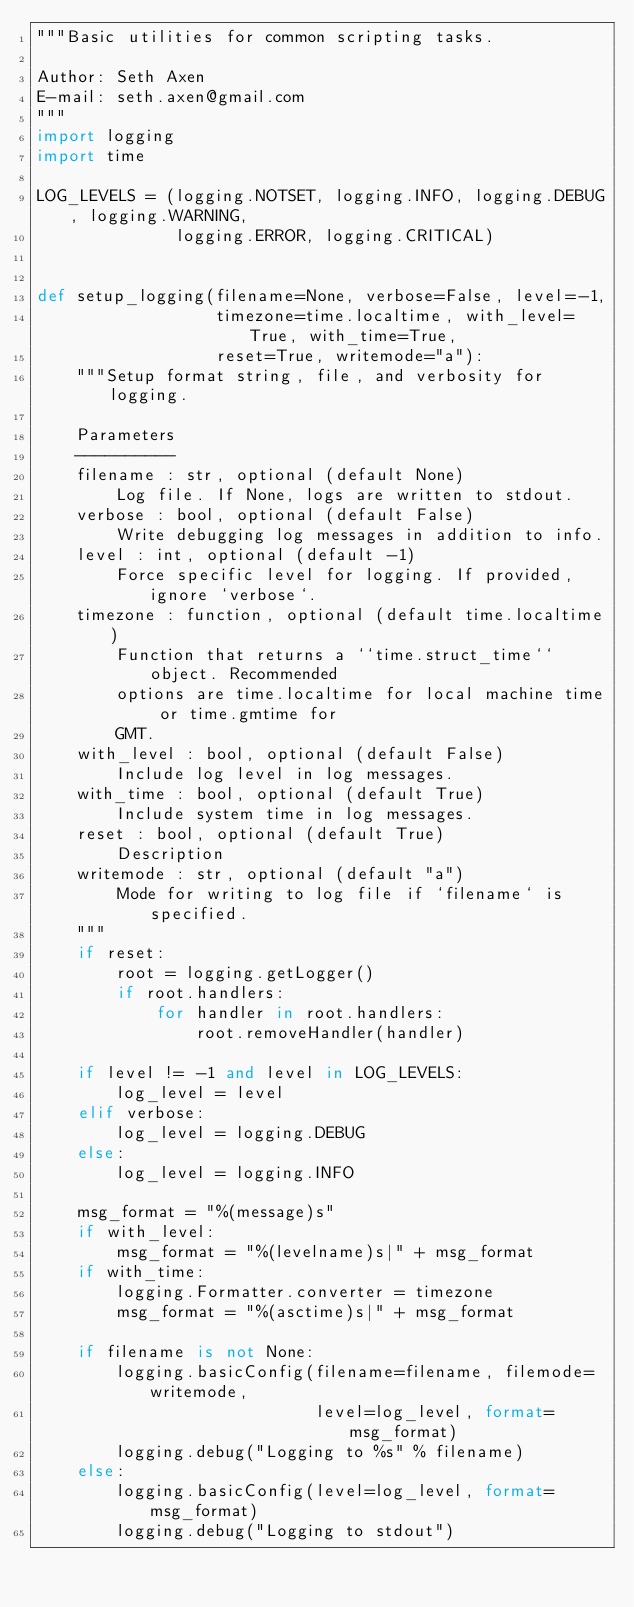<code> <loc_0><loc_0><loc_500><loc_500><_Python_>"""Basic utilities for common scripting tasks.

Author: Seth Axen
E-mail: seth.axen@gmail.com
"""
import logging
import time

LOG_LEVELS = (logging.NOTSET, logging.INFO, logging.DEBUG, logging.WARNING,
              logging.ERROR, logging.CRITICAL)


def setup_logging(filename=None, verbose=False, level=-1,
                  timezone=time.localtime, with_level=True, with_time=True,
                  reset=True, writemode="a"):
    """Setup format string, file, and verbosity for logging.

    Parameters
    ----------
    filename : str, optional (default None)
        Log file. If None, logs are written to stdout.
    verbose : bool, optional (default False)
        Write debugging log messages in addition to info.
    level : int, optional (default -1)
        Force specific level for logging. If provided, ignore `verbose`.
    timezone : function, optional (default time.localtime)
        Function that returns a ``time.struct_time`` object. Recommended
        options are time.localtime for local machine time or time.gmtime for
        GMT.
    with_level : bool, optional (default False)
        Include log level in log messages.
    with_time : bool, optional (default True)
        Include system time in log messages.
    reset : bool, optional (default True)
        Description
    writemode : str, optional (default "a")
        Mode for writing to log file if `filename` is specified.
    """
    if reset:
        root = logging.getLogger()
        if root.handlers:
            for handler in root.handlers:
                root.removeHandler(handler)

    if level != -1 and level in LOG_LEVELS:
        log_level = level
    elif verbose:
        log_level = logging.DEBUG
    else:
        log_level = logging.INFO

    msg_format = "%(message)s"
    if with_level:
        msg_format = "%(levelname)s|" + msg_format
    if with_time:
        logging.Formatter.converter = timezone
        msg_format = "%(asctime)s|" + msg_format

    if filename is not None:
        logging.basicConfig(filename=filename, filemode=writemode,
                            level=log_level, format=msg_format)
        logging.debug("Logging to %s" % filename)
    else:
        logging.basicConfig(level=log_level, format=msg_format)
        logging.debug("Logging to stdout")
</code> 